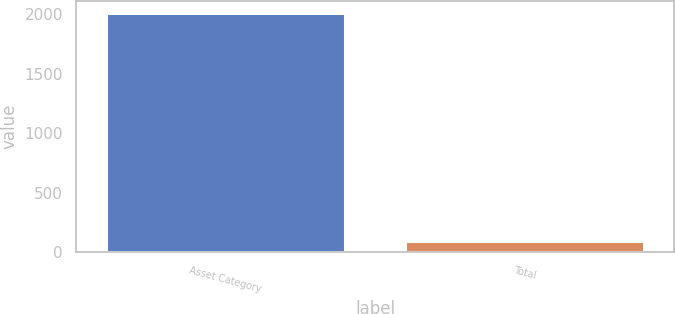<chart> <loc_0><loc_0><loc_500><loc_500><bar_chart><fcel>Asset Category<fcel>Total<nl><fcel>2012<fcel>100<nl></chart> 